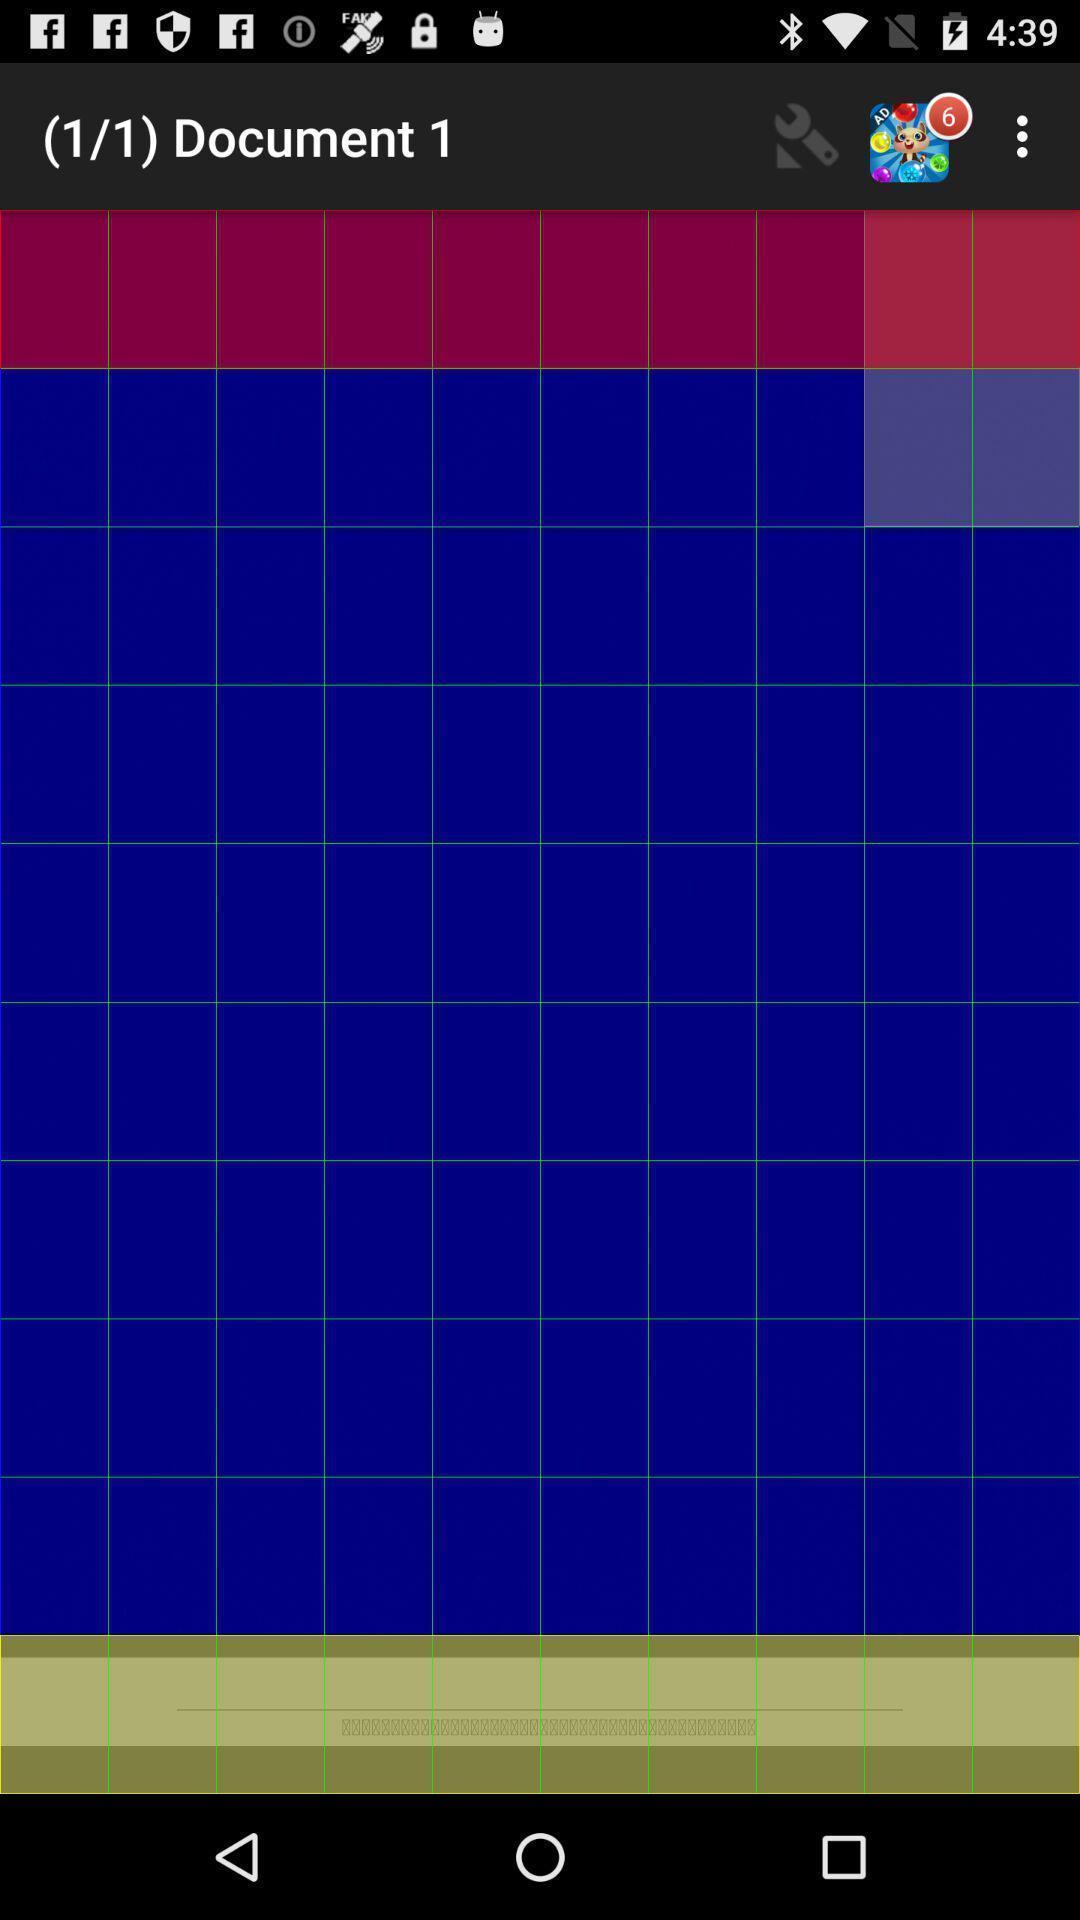What can you discern from this picture? Screen showing blank page in document tab. 